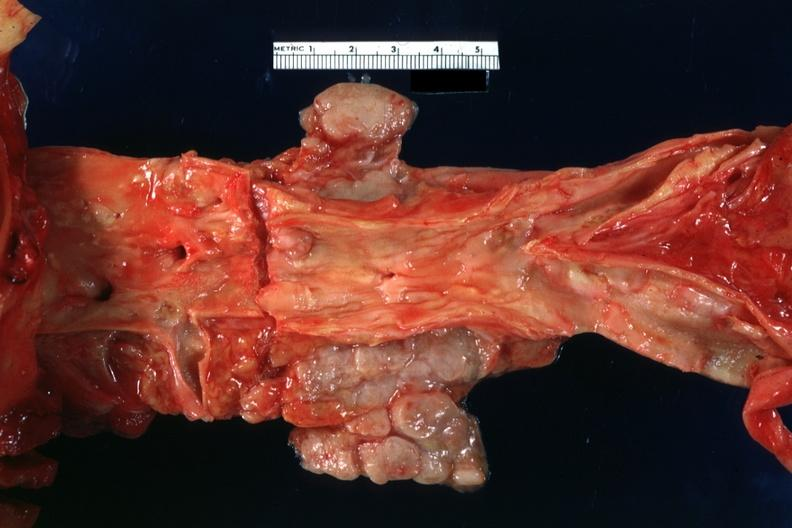does this image show periaortic nodes with metastatic carcinoma aorta shows good atherosclerotic plaques?
Answer the question using a single word or phrase. Yes 